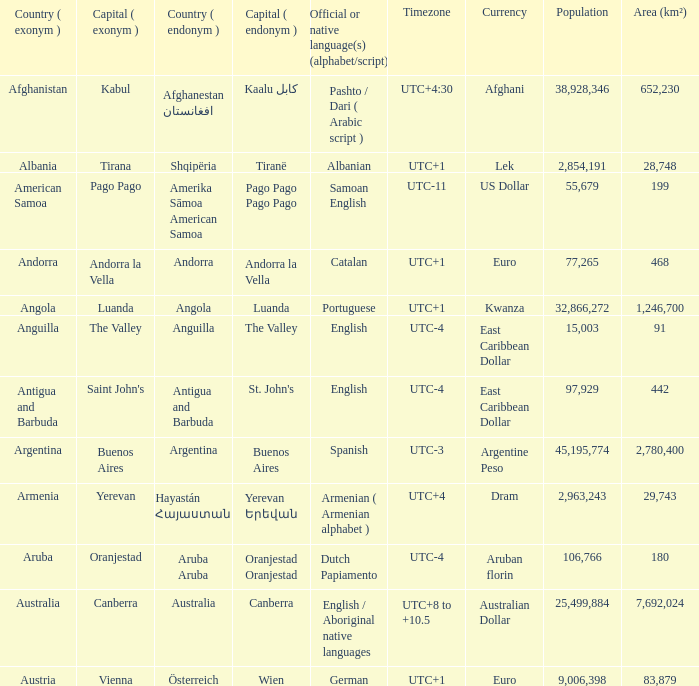What is the English name of the country whose official native language is Dutch Papiamento? Aruba. 